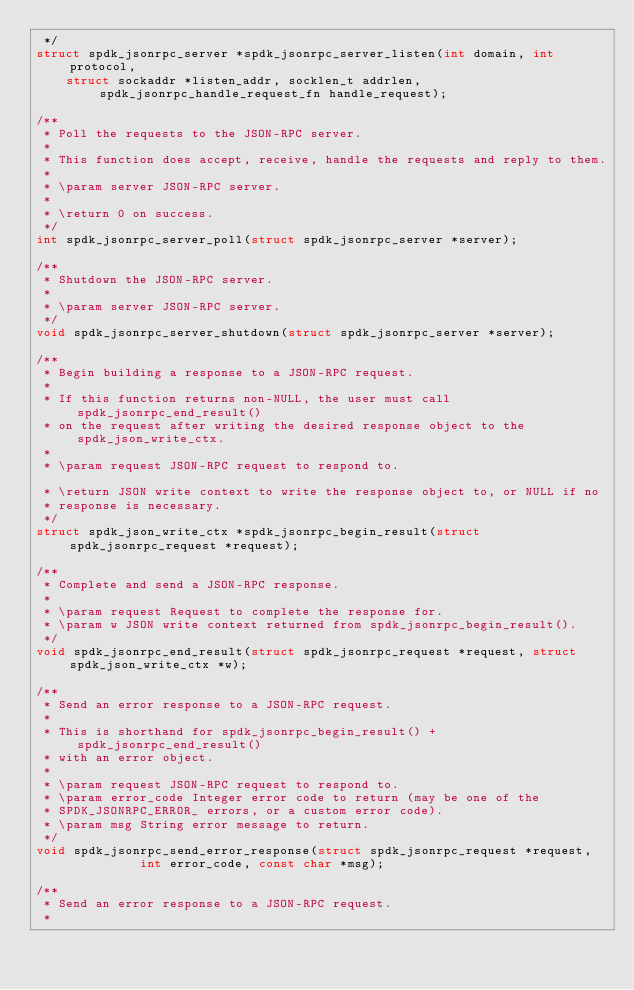<code> <loc_0><loc_0><loc_500><loc_500><_C_> */
struct spdk_jsonrpc_server *spdk_jsonrpc_server_listen(int domain, int protocol,
		struct sockaddr *listen_addr, socklen_t addrlen, spdk_jsonrpc_handle_request_fn handle_request);

/**
 * Poll the requests to the JSON-RPC server.
 *
 * This function does accept, receive, handle the requests and reply to them.
 *
 * \param server JSON-RPC server.
 *
 * \return 0 on success.
 */
int spdk_jsonrpc_server_poll(struct spdk_jsonrpc_server *server);

/**
 * Shutdown the JSON-RPC server.
 *
 * \param server JSON-RPC server.
 */
void spdk_jsonrpc_server_shutdown(struct spdk_jsonrpc_server *server);

/**
 * Begin building a response to a JSON-RPC request.
 *
 * If this function returns non-NULL, the user must call spdk_jsonrpc_end_result()
 * on the request after writing the desired response object to the spdk_json_write_ctx.
 *
 * \param request JSON-RPC request to respond to.

 * \return JSON write context to write the response object to, or NULL if no
 * response is necessary.
 */
struct spdk_json_write_ctx *spdk_jsonrpc_begin_result(struct spdk_jsonrpc_request *request);

/**
 * Complete and send a JSON-RPC response.
 *
 * \param request Request to complete the response for.
 * \param w JSON write context returned from spdk_jsonrpc_begin_result().
 */
void spdk_jsonrpc_end_result(struct spdk_jsonrpc_request *request, struct spdk_json_write_ctx *w);

/**
 * Send an error response to a JSON-RPC request.
 *
 * This is shorthand for spdk_jsonrpc_begin_result() + spdk_jsonrpc_end_result()
 * with an error object.
 *
 * \param request JSON-RPC request to respond to.
 * \param error_code Integer error code to return (may be one of the
 * SPDK_JSONRPC_ERROR_ errors, or a custom error code).
 * \param msg String error message to return.
 */
void spdk_jsonrpc_send_error_response(struct spdk_jsonrpc_request *request,
				      int error_code, const char *msg);

/**
 * Send an error response to a JSON-RPC request.
 *</code> 